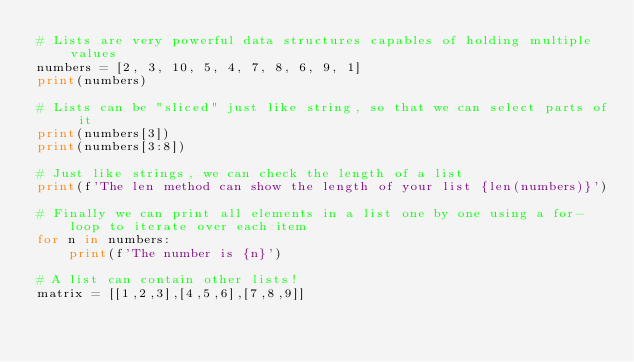<code> <loc_0><loc_0><loc_500><loc_500><_Python_># Lists are very powerful data structures capables of holding multiple values
numbers = [2, 3, 10, 5, 4, 7, 8, 6, 9, 1]
print(numbers)

# Lists can be "sliced" just like string, so that we can select parts of it
print(numbers[3])
print(numbers[3:8])

# Just like strings, we can check the length of a list
print(f'The len method can show the length of your list {len(numbers)}')

# Finally we can print all elements in a list one by one using a for-loop to iterate over each item
for n in numbers:
    print(f'The number is {n}')

# A list can contain other lists!
matrix = [[1,2,3],[4,5,6],[7,8,9]]</code> 